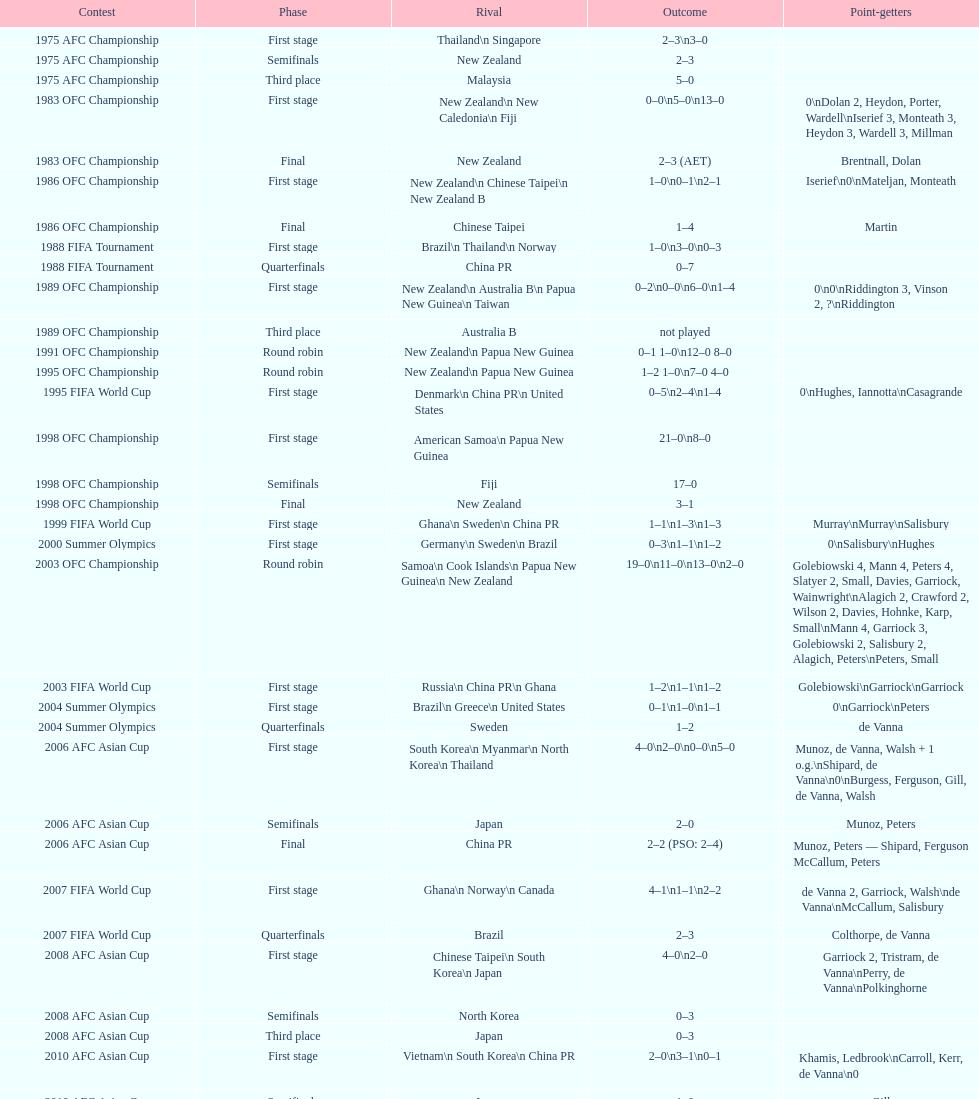How many stages were round robins? 3. 